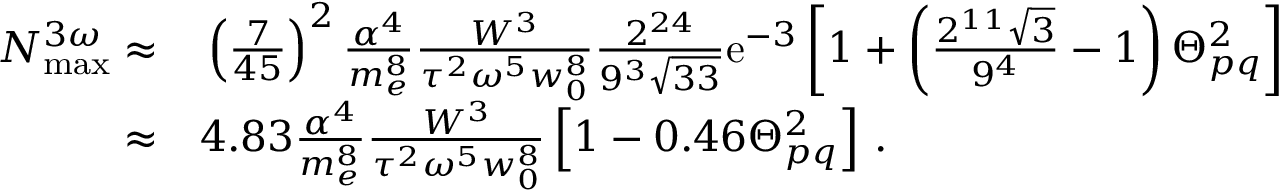Convert formula to latex. <formula><loc_0><loc_0><loc_500><loc_500>\begin{array} { r l } { N _ { \max } ^ { 3 \omega } \approx } & \left ( \frac { 7 } { 4 5 } \right ) ^ { 2 } \frac { \alpha ^ { 4 } } { m _ { e } ^ { 8 } } \frac { W ^ { 3 } } { \tau ^ { 2 } \omega ^ { 5 } w _ { 0 } ^ { 8 } } \frac { 2 ^ { 2 4 } } { 9 ^ { 3 } \sqrt { 3 3 } } e ^ { - 3 } \left [ 1 + \left ( \frac { 2 ^ { 1 1 } \sqrt { 3 } } { 9 ^ { 4 } } - 1 \right ) \Theta _ { p q } ^ { 2 } \right ] } \\ { \approx } & 4 . 8 3 \frac { \alpha ^ { 4 } } { m _ { e } ^ { 8 } } \frac { W ^ { 3 } } { \tau ^ { 2 } \omega ^ { 5 } w _ { 0 } ^ { 8 } } \left [ 1 - 0 . 4 6 \Theta _ { p q } ^ { 2 } \right ] \, . } \end{array}</formula> 